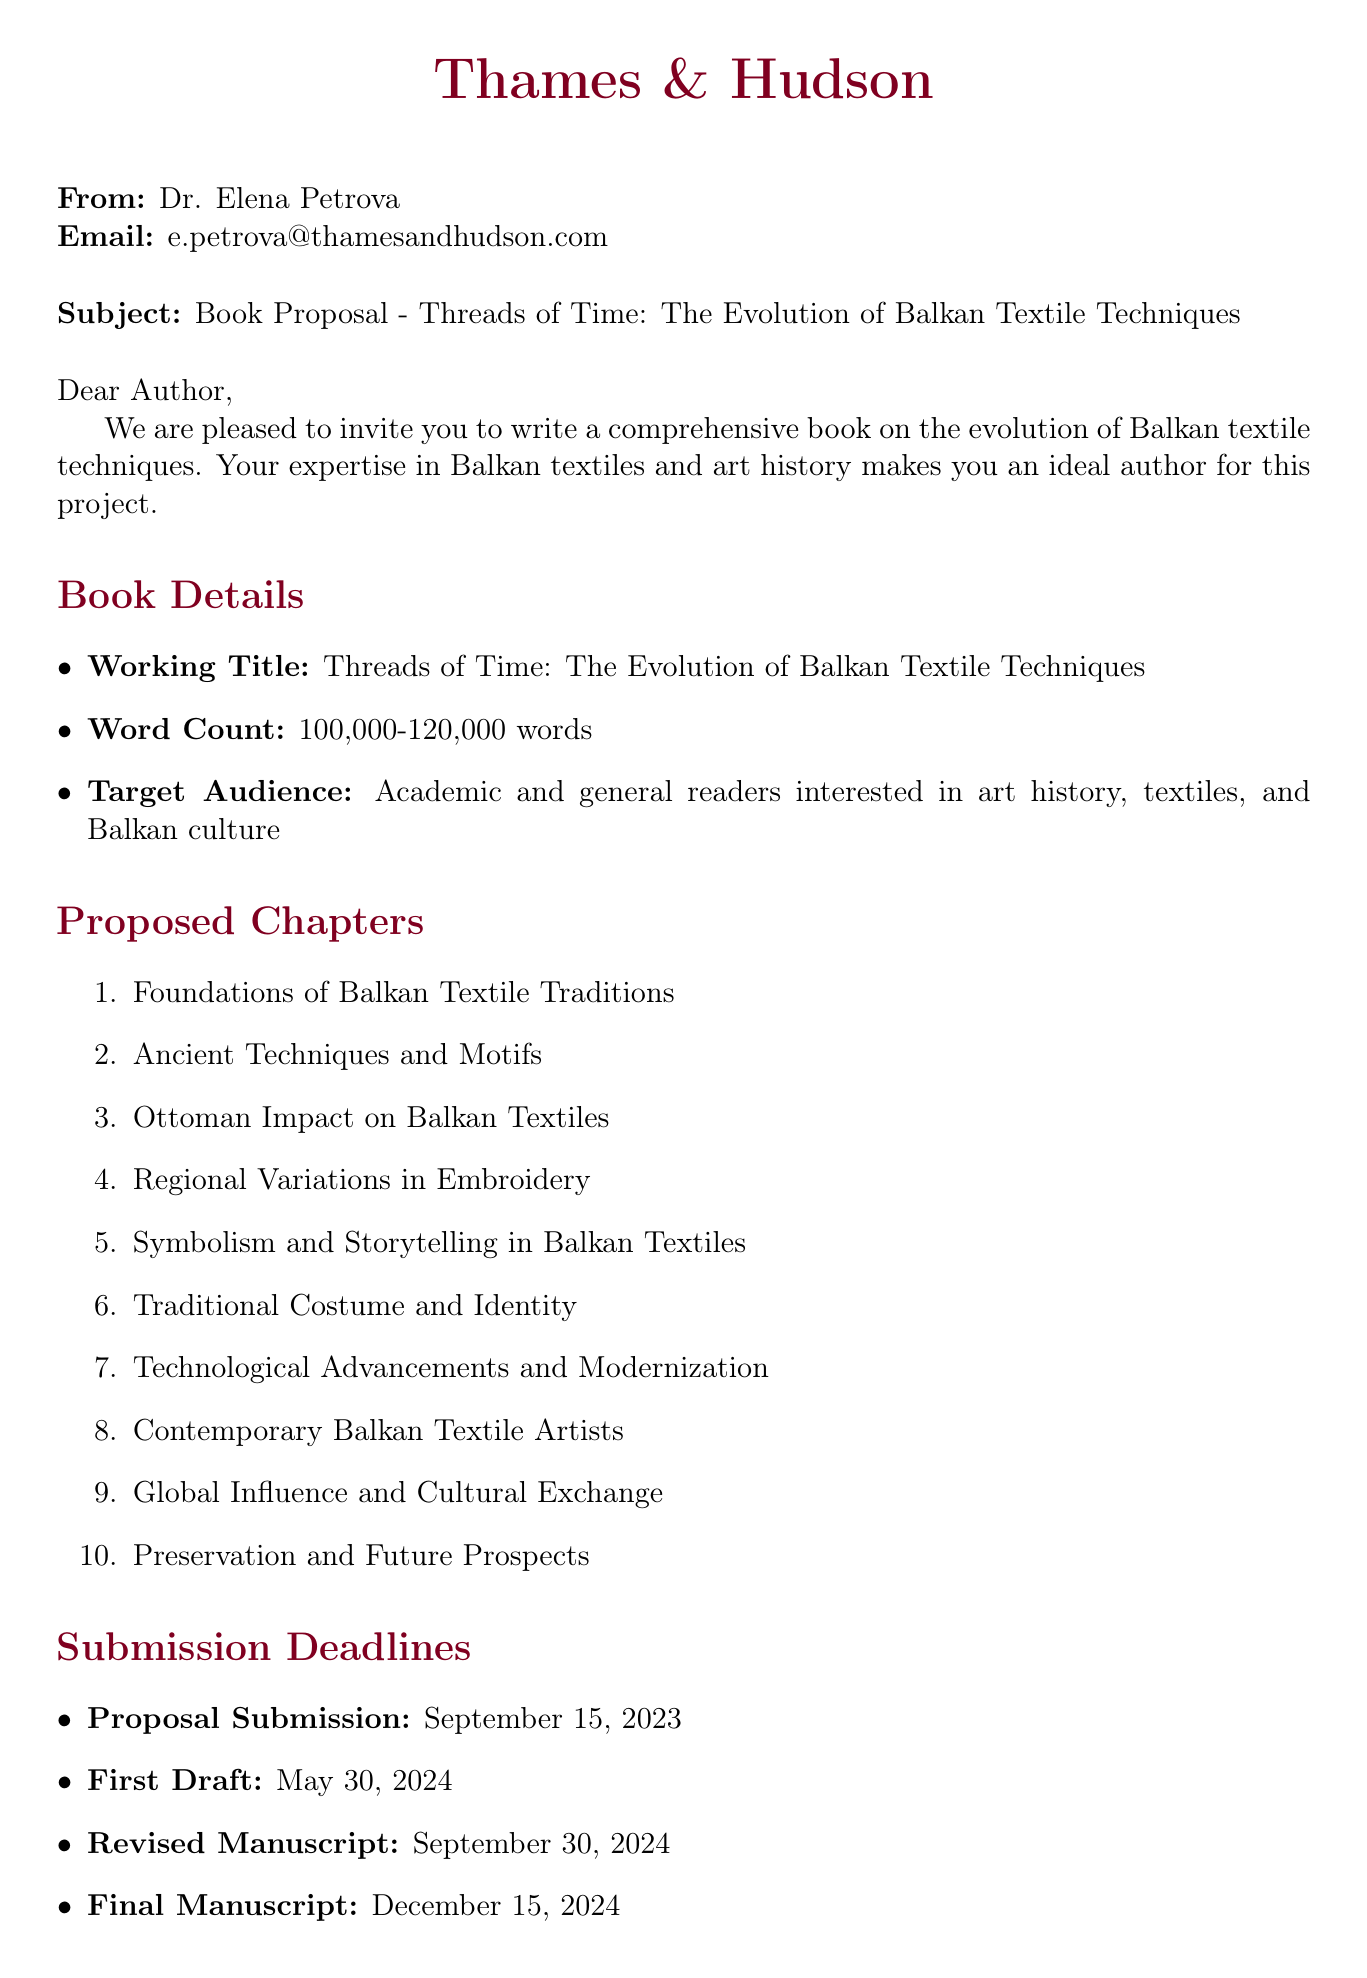What is the working title of the book? The working title is stated in the book details section of the document.
Answer: Threads of Time: The Evolution of Balkan Textile Techniques Who is the editor at Thames & Hudson? The editor's name is provided at the beginning of the document.
Answer: Dr. Elena Petrova What is the word count range for the book? The word count range is specified in the book details section.
Answer: 100,000-120,000 words When is the first draft due? The deadline for the first draft is mentioned in the submission deadlines section.
Answer: May 30, 2024 How many proposed chapters are listed? The total number of proposed chapters can be counted from the enumeration in the chapters section.
Answer: 10 What is the target audience for the book? The target audience is identified in the book details section.
Answer: Academic and general readers interested in art history, textiles, and Balkan culture What additional requirement is specified regarding images? This requirement can be found in the additional requirements section of the document.
Answer: 150-200 high-quality photographs and illustrations Which institution is listed as a research resource located in Sarajevo? The location and name of the institution can be found in the research resources section.
Answer: National Museum of Bosnia and Herzegovina, Sarajevo Who is the first potential collaborator mentioned? The first potential collaborator's information is given in the potential collaborators section.
Answer: Dr. Mirjana Menković What is the submission deadline for the proposal? This specific date is provided in the submission deadlines section.
Answer: September 15, 2023 